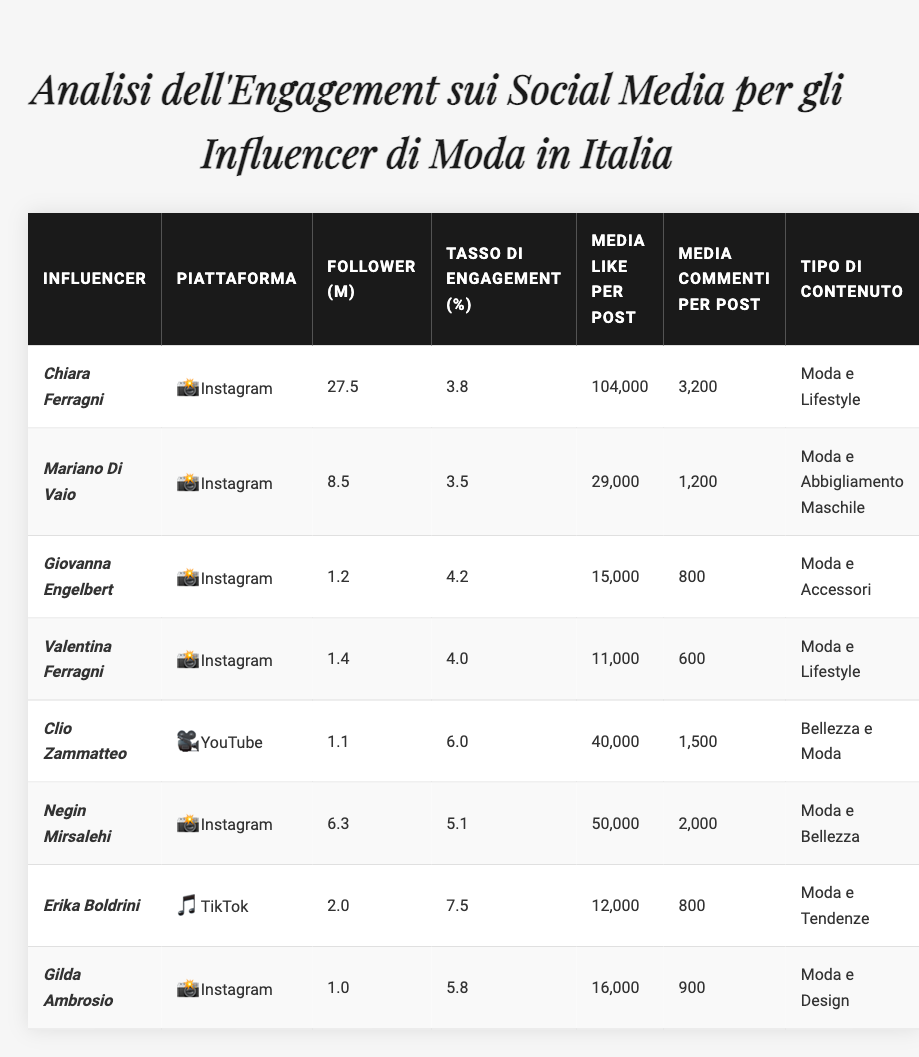What's the total number of followers of all listed influencers? To find the total followers, I will sum the values: 27.5 + 8.5 + 1.2 + 1.4 + 1.1 + 6.3 + 2.0 + 1.0 = 49.0 million.
Answer: 49.0 million Which influencer has the highest average engagement rate? By examining the engagement rates, I see that Erika Boldrini has the highest rate at 7.5%.
Answer: Erika Boldrini What is the average number of likes per post across all influencers? I will calculate the average likes by summing the likes: (104000 + 29000 + 15000 + 11000 + 40000 + 50000 + 12000 + 16000) = 239000. Then, divide by 8 influencers: 239000 / 8 = 29875.
Answer: 29,875 Is Clio Zammatteo an influencer on Instagram? From the table, Clio Zammatteo is listed under YouTube, not Instagram.
Answer: No What is the difference in average comments per post between Negin Mirsalehi and Gilda Ambrosio? Negin Mirsalehi has 2000 comments, and Gilda Ambrosio has 900 comments. The difference is 2000 - 900 = 1100.
Answer: 1100 Which content type has the highest engagement rate and what is that rate? I'll look for the highest engagement rate: Erika Boldrini (7.5%) and Clio Zammatteo (6.0%) are the highest. Since Erika Boldrini has the highest rate among the others, the top content type is "Fashion & Trends" at 7.5%.
Answer: Fashion & Trends, 7.5% How many influencers primarily focus on Fashion & Lifestyle content? Chiara Ferragni and Valentina Ferragni are both focusing on Fashion & Lifestyle, totaling 2 influencers.
Answer: 2 What is the average engagement rate of influencers on Instagram? I calculate the average engagement rate for Instagram influencers (Chiara Ferragni, Mariano Di Vaio, Giovanna Engelbert, Valentina Ferragni, Negin Mirsalehi, Gilda Ambrosio) as follows: (3.8 + 3.5 + 4.2 + 4.0 + 5.1 + 5.8) = 26.4. Then divide by 6: 26.4 / 6 = 4.4%.
Answer: 4.4% Which platform has the least number of total followers among listed influencers? Analyzing the followers: Instagram has the highest with Chiara Ferragni (27.5M), followed by TikTok with Erika Boldrini (2.0M), and YouTube with Clio Zammatteo (1.1M). Therefore, YouTube has the least total followers.
Answer: YouTube Are there any influencers with an engagement rate over 5%? Yes, Erika Boldrini (7.5%), Negin Mirsalehi (5.1%), and Gilda Ambrosio (5.8%) all have engagement rates over 5%.
Answer: Yes 